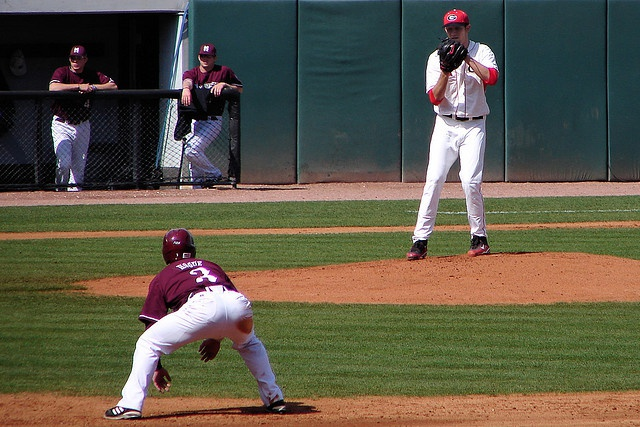Describe the objects in this image and their specific colors. I can see people in gray, white, black, and darkgray tones, people in gray, lavender, maroon, and black tones, people in gray, black, and maroon tones, people in gray, black, purple, and lavender tones, and baseball glove in gray, black, and maroon tones in this image. 